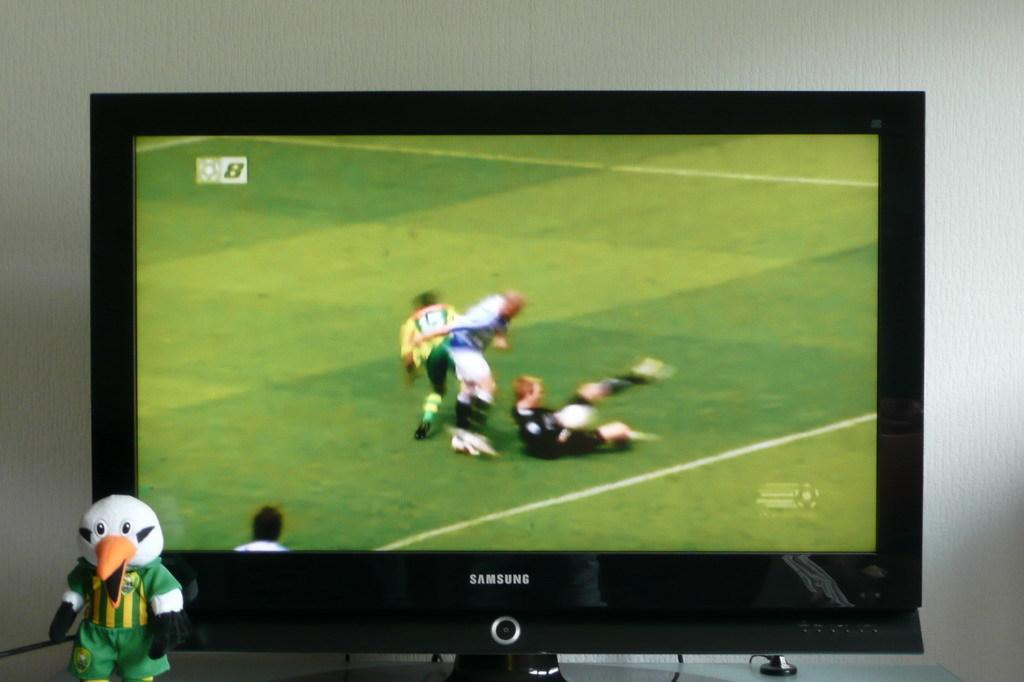<image>
Give a short and clear explanation of the subsequent image. a television with the word samsung on the television 